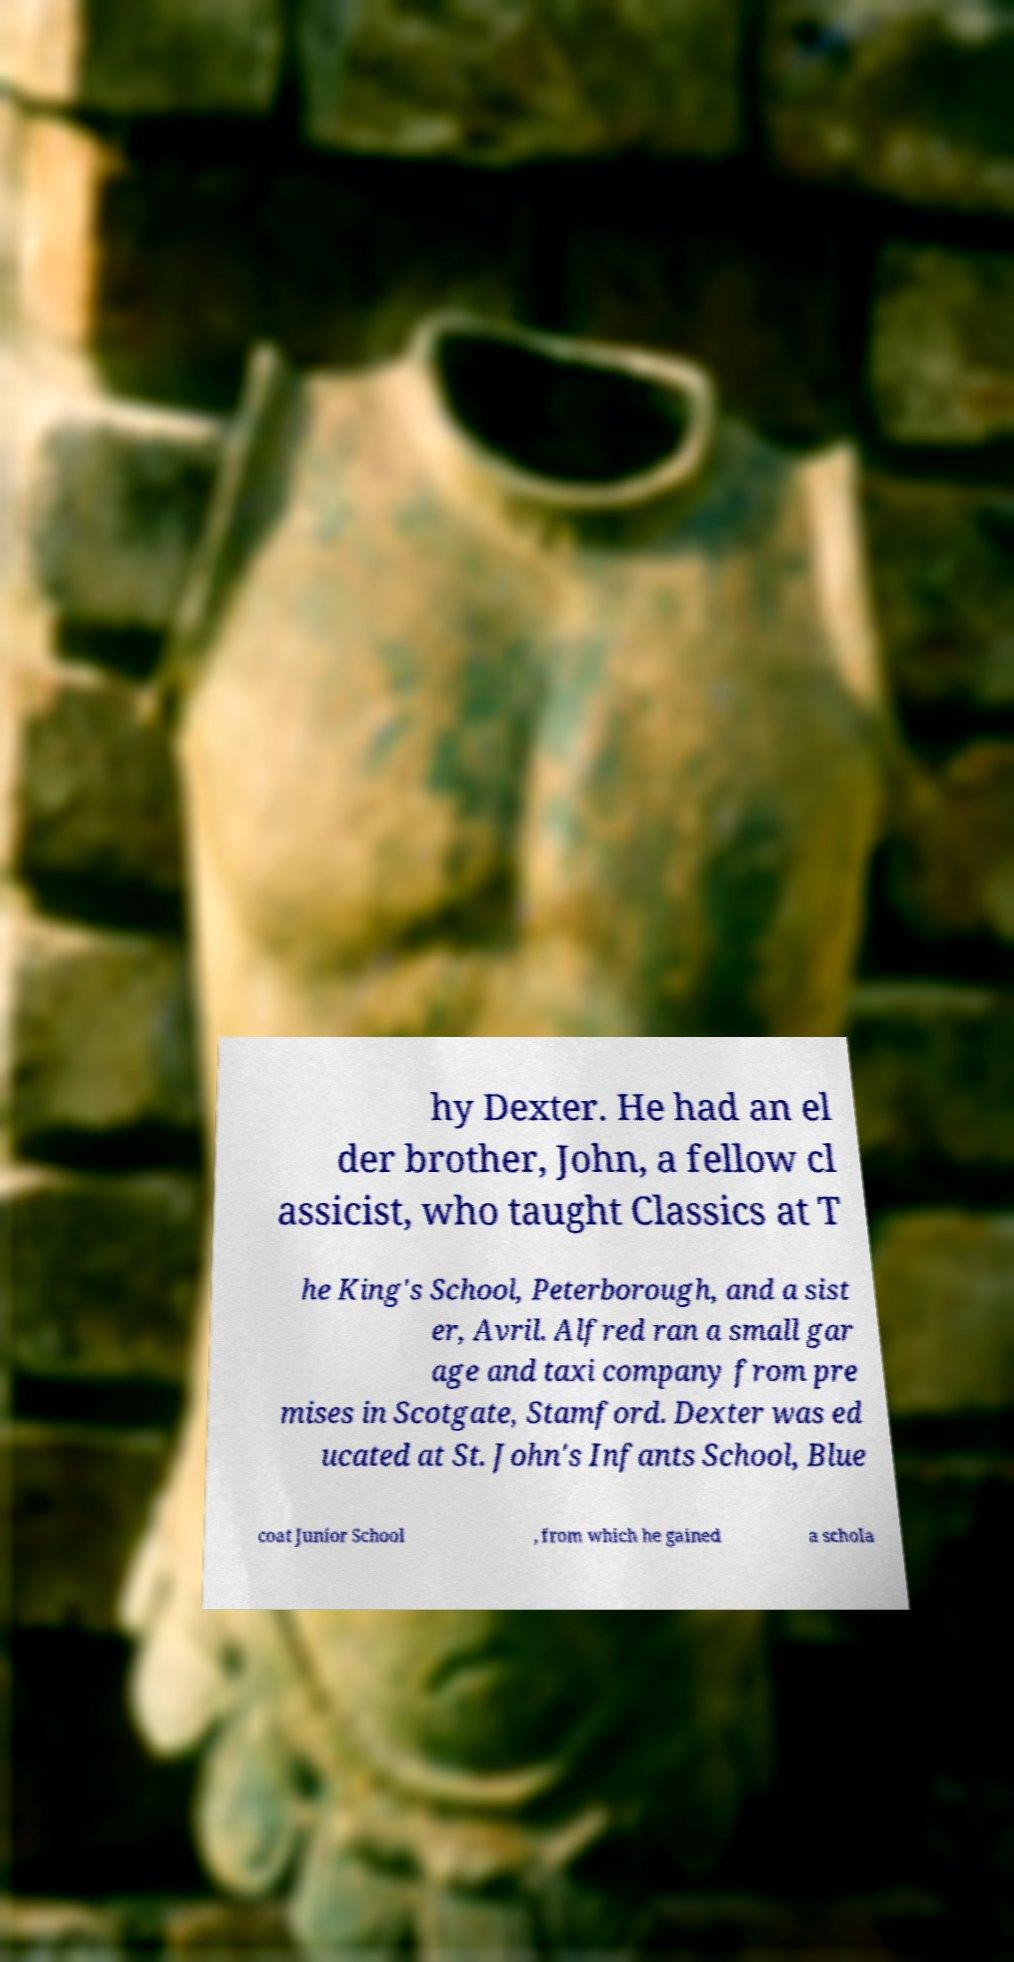Could you extract and type out the text from this image? hy Dexter. He had an el der brother, John, a fellow cl assicist, who taught Classics at T he King's School, Peterborough, and a sist er, Avril. Alfred ran a small gar age and taxi company from pre mises in Scotgate, Stamford. Dexter was ed ucated at St. John's Infants School, Blue coat Junior School , from which he gained a schola 